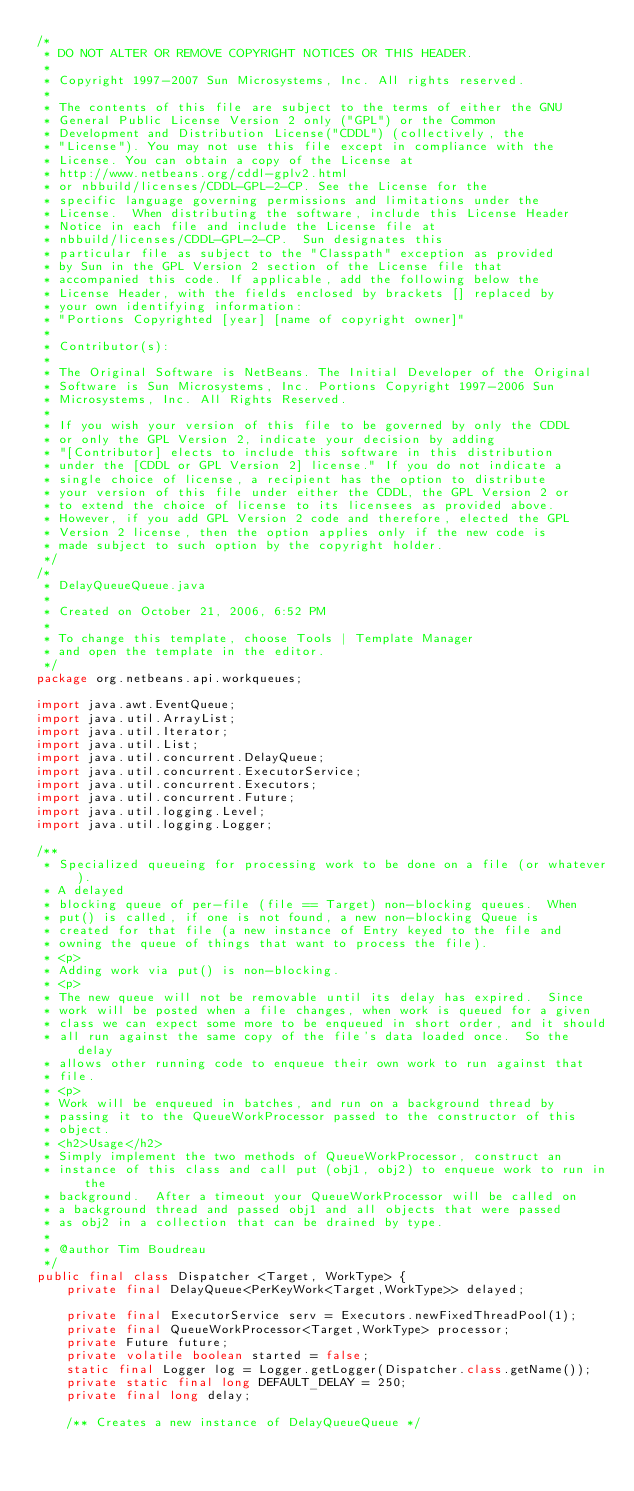Convert code to text. <code><loc_0><loc_0><loc_500><loc_500><_Java_>/*
 * DO NOT ALTER OR REMOVE COPYRIGHT NOTICES OR THIS HEADER.
 *
 * Copyright 1997-2007 Sun Microsystems, Inc. All rights reserved.
 *
 * The contents of this file are subject to the terms of either the GNU
 * General Public License Version 2 only ("GPL") or the Common
 * Development and Distribution License("CDDL") (collectively, the
 * "License"). You may not use this file except in compliance with the
 * License. You can obtain a copy of the License at
 * http://www.netbeans.org/cddl-gplv2.html
 * or nbbuild/licenses/CDDL-GPL-2-CP. See the License for the
 * specific language governing permissions and limitations under the
 * License.  When distributing the software, include this License Header
 * Notice in each file and include the License file at
 * nbbuild/licenses/CDDL-GPL-2-CP.  Sun designates this
 * particular file as subject to the "Classpath" exception as provided
 * by Sun in the GPL Version 2 section of the License file that
 * accompanied this code. If applicable, add the following below the
 * License Header, with the fields enclosed by brackets [] replaced by
 * your own identifying information:
 * "Portions Copyrighted [year] [name of copyright owner]"
 *
 * Contributor(s):
 *
 * The Original Software is NetBeans. The Initial Developer of the Original
 * Software is Sun Microsystems, Inc. Portions Copyright 1997-2006 Sun
 * Microsystems, Inc. All Rights Reserved.
 *
 * If you wish your version of this file to be governed by only the CDDL
 * or only the GPL Version 2, indicate your decision by adding
 * "[Contributor] elects to include this software in this distribution
 * under the [CDDL or GPL Version 2] license." If you do not indicate a
 * single choice of license, a recipient has the option to distribute
 * your version of this file under either the CDDL, the GPL Version 2 or
 * to extend the choice of license to its licensees as provided above.
 * However, if you add GPL Version 2 code and therefore, elected the GPL
 * Version 2 license, then the option applies only if the new code is
 * made subject to such option by the copyright holder.
 */
/*
 * DelayQueueQueue.java
 *
 * Created on October 21, 2006, 6:52 PM
 *
 * To change this template, choose Tools | Template Manager
 * and open the template in the editor.
 */ 
package org.netbeans.api.workqueues;

import java.awt.EventQueue;
import java.util.ArrayList;
import java.util.Iterator;
import java.util.List;
import java.util.concurrent.DelayQueue;
import java.util.concurrent.ExecutorService;
import java.util.concurrent.Executors;
import java.util.concurrent.Future;
import java.util.logging.Level;
import java.util.logging.Logger;

/**
 * Specialized queueing for processing work to be done on a file (or whatever).  
 * A delayed
 * blocking queue of per-file (file == Target) non-blocking queues.  When
 * put() is called, if one is not found, a new non-blocking Queue is
 * created for that file (a new instance of Entry keyed to the file and
 * owning the queue of things that want to process the file).
 * <p>
 * Adding work via put() is non-blocking.
 * <p>
 * The new queue will not be removable until its delay has expired.  Since
 * work will be posted when a file changes, when work is queued for a given
 * class we can expect some more to be enqueued in short order, and it should
 * all run against the same copy of the file's data loaded once.  So the delay
 * allows other running code to enqueue their own work to run against that
 * file.
 * <p>
 * Work will be enqueued in batches, and run on a background thread by
 * passing it to the QueueWorkProcessor passed to the constructor of this
 * object.
 * <h2>Usage</h2>
 * Simply implement the two methods of QueueWorkProcessor, construct an
 * instance of this class and call put (obj1, obj2) to enqueue work to run in the
 * background.  After a timeout your QueueWorkProcessor will be called on
 * a background thread and passed obj1 and all objects that were passed
 * as obj2 in a collection that can be drained by type.
 *
 * @author Tim Boudreau
 */
public final class Dispatcher <Target, WorkType> {
    private final DelayQueue<PerKeyWork<Target,WorkType>> delayed;
            
    private final ExecutorService serv = Executors.newFixedThreadPool(1);
    private final QueueWorkProcessor<Target,WorkType> processor;
    private Future future;
    private volatile boolean started = false;
    static final Logger log = Logger.getLogger(Dispatcher.class.getName());
    private static final long DEFAULT_DELAY = 250;
    private final long delay;
    
    /** Creates a new instance of DelayQueueQueue */</code> 